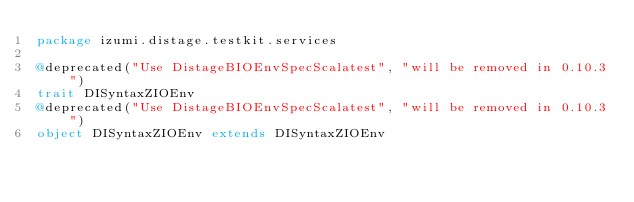Convert code to text. <code><loc_0><loc_0><loc_500><loc_500><_Scala_>package izumi.distage.testkit.services

@deprecated("Use DistageBIOEnvSpecScalatest", "will be removed in 0.10.3")
trait DISyntaxZIOEnv
@deprecated("Use DistageBIOEnvSpecScalatest", "will be removed in 0.10.3")
object DISyntaxZIOEnv extends DISyntaxZIOEnv
</code> 